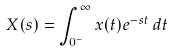<formula> <loc_0><loc_0><loc_500><loc_500>X ( s ) = \int _ { 0 ^ { - } } ^ { \infty } x ( t ) e ^ { - s t } \, d t</formula> 